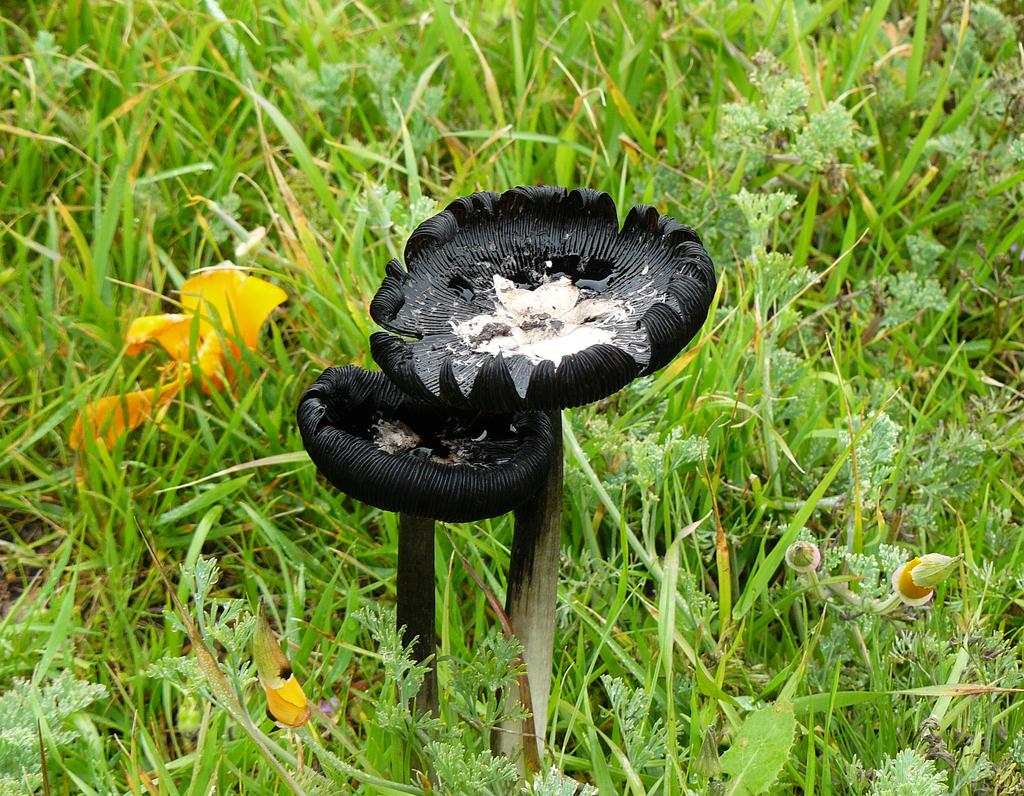What type of fungi can be seen in the image? There are two black mushrooms in the image. Where are the mushrooms located? The mushrooms are in between the grass. What other plants are present in the image? There are many unwanted plants around the mushrooms. What type of shock can be seen in the image? There is no shock present in the image; it features two black mushrooms and unwanted plants. Is there a crook in the image? There is no crook present in the image. 